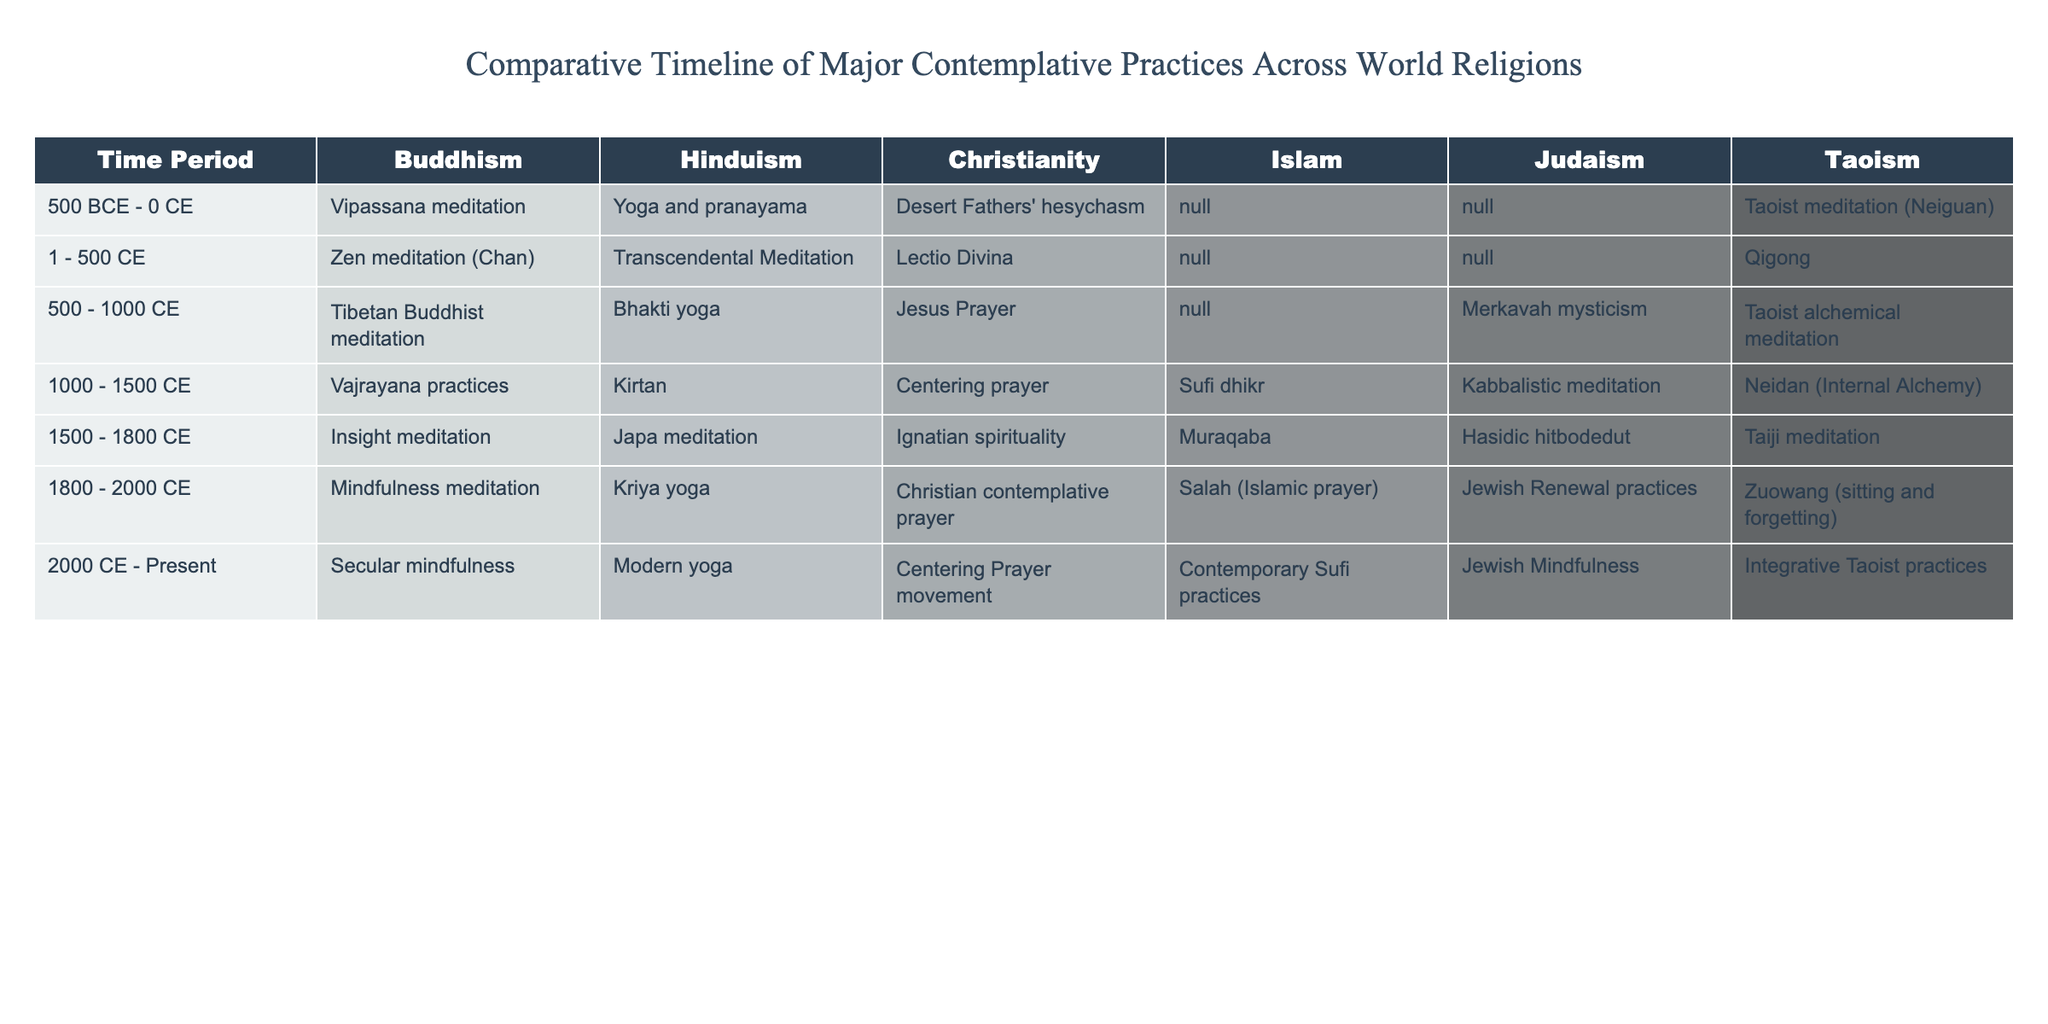What contemplative practices are associated with Buddhism between 500 BCE and 0 CE? In the table, under the Buddhism column for the time period "500 BCE - 0 CE," the contemplative practice listed is "Vipassana meditation."
Answer: Vipassana meditation Which contemplative practice is common to both Christianity and Islam from 1000 to 1500 CE? In the table, the contemplative practices listed for Christianity and Islam during the time period "1000 - 1500 CE" are "Centering prayer" and "Sufi dhikr," respectively. Since the question asks for common practices and none are listed, the answer is none.
Answer: None What is the last contemplative practice mentioned for Taoism in the 2000 CE to Present period? Referring to the table, in the Taoism column for the time period "2000 CE - Present," the contemplative practice listed is "Integrative Taoist practices."
Answer: Integrative Taoist practices Which religious tradition shows the earliest recorded contemplative practice according to the timeline? Looking at the first row of the table, Buddhism has "Vipassana meditation" recorded as its contemplative practice in the earliest time period of "500 BCE - 0 CE."
Answer: Buddhism Which contemplative practices from Judaism were practiced between 1500 and 1800 CE? In the table section for Judaism during "1500 - 1800 CE," the listed contemplative practice is "Hasidic hitbodedut."
Answer: Hasidic hitbodedut In which time period did "Mindfulness meditation" first appear, according to the table? The table indicates that "Mindfulness meditation" appeared in the time period labeled "1800 - 2000 CE."
Answer: 1800 - 2000 CE How many contemplative practices appear in the column for Hinduism between 500 and 1000 CE? Between "500 - 1000 CE," the table shows one practice for Hinduism: "Bhakti yoga." Therefore, there is one practice listed.
Answer: 1 Does Christianity include any contemplative practices from 2000 CE to Present? In the table's "2000 CE - Present" section, the contemplative practice listed under Christianity is "Centering Prayer movement," indicating that it does include practices.
Answer: Yes What are the contemplative practices across all religions during the time period of 1500 to 1800 CE? In this time period, the practices listed are: Buddhism - Insight meditation, Hinduism - Japa meditation, Christianity - Ignatian spirituality, Islam - Muraqaba, Judaism - Hasidic hitbodedut, and Taoism - Taiji meditation.
Answer: Insight meditation, Japa meditation, Ignatian spirituality, Muraqaba, Hasidic hitbodedut, Taiji meditation Which religious tradition had a contemplative practice listed in every time period according to the table? Reviewing the table reveals that Buddhism has a practice listed in every time period, from Vipassana to Secular mindfulness. Therefore, Buddhism is the tradition with continuous representation.
Answer: Buddhism 